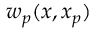<formula> <loc_0><loc_0><loc_500><loc_500>w _ { p } ( x , x _ { p } )</formula> 